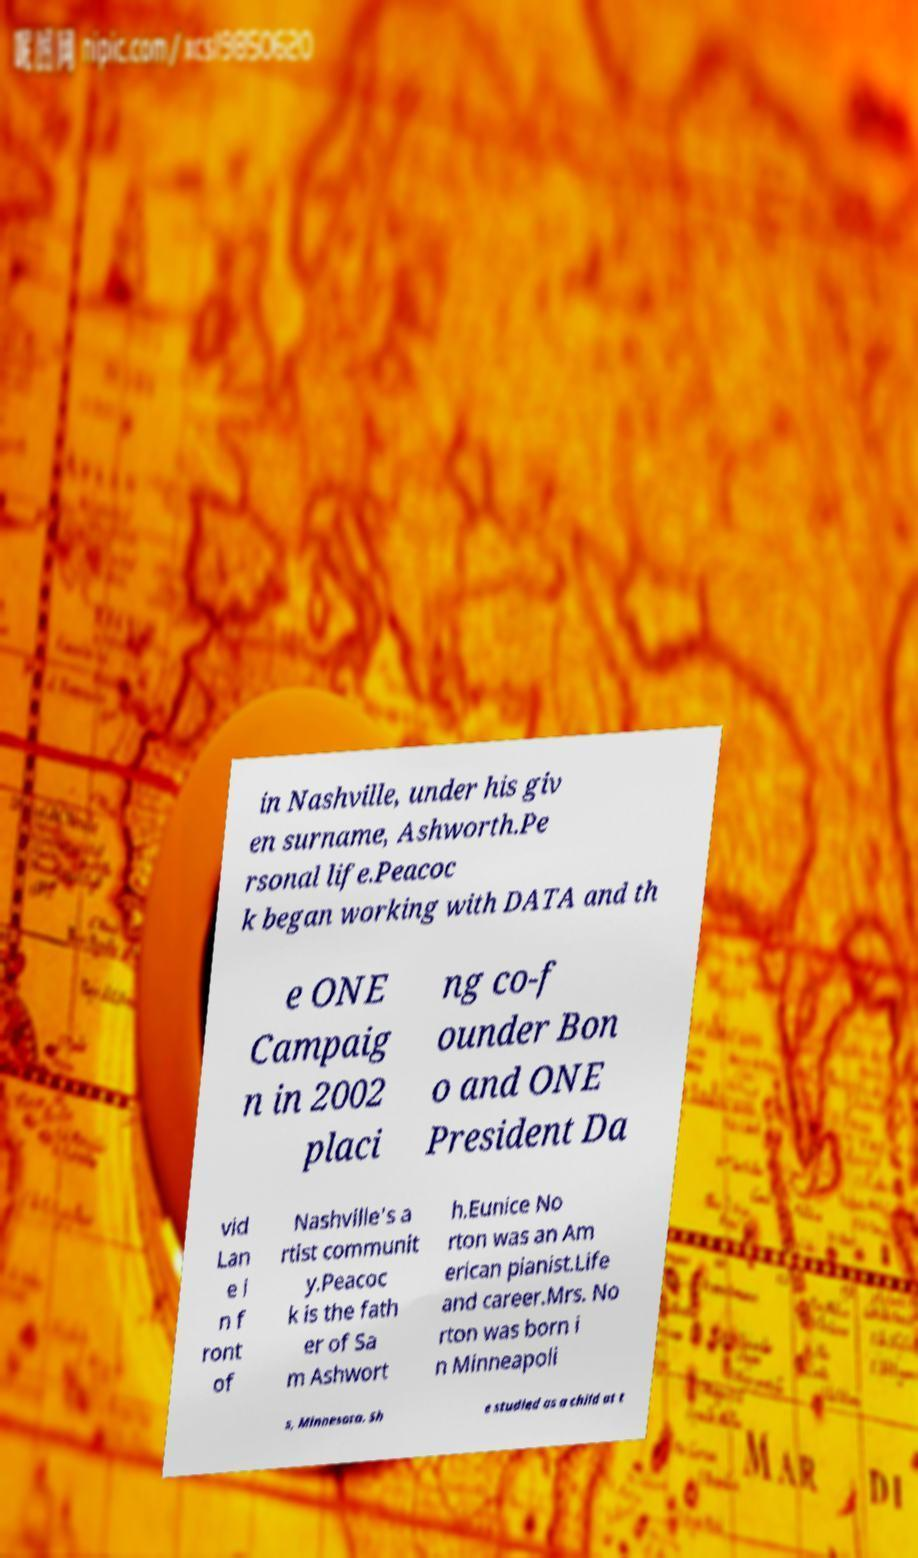Please identify and transcribe the text found in this image. in Nashville, under his giv en surname, Ashworth.Pe rsonal life.Peacoc k began working with DATA and th e ONE Campaig n in 2002 placi ng co-f ounder Bon o and ONE President Da vid Lan e i n f ront of Nashville's a rtist communit y.Peacoc k is the fath er of Sa m Ashwort h.Eunice No rton was an Am erican pianist.Life and career.Mrs. No rton was born i n Minneapoli s, Minnesota. Sh e studied as a child at t 